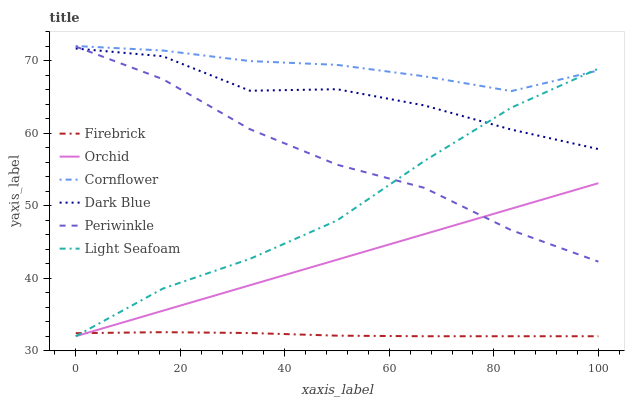Does Firebrick have the minimum area under the curve?
Answer yes or no. Yes. Does Cornflower have the maximum area under the curve?
Answer yes or no. Yes. Does Dark Blue have the minimum area under the curve?
Answer yes or no. No. Does Dark Blue have the maximum area under the curve?
Answer yes or no. No. Is Orchid the smoothest?
Answer yes or no. Yes. Is Dark Blue the roughest?
Answer yes or no. Yes. Is Firebrick the smoothest?
Answer yes or no. No. Is Firebrick the roughest?
Answer yes or no. No. Does Firebrick have the lowest value?
Answer yes or no. Yes. Does Dark Blue have the lowest value?
Answer yes or no. No. Does Cornflower have the highest value?
Answer yes or no. Yes. Does Dark Blue have the highest value?
Answer yes or no. No. Is Firebrick less than Periwinkle?
Answer yes or no. Yes. Is Periwinkle greater than Firebrick?
Answer yes or no. Yes. Does Periwinkle intersect Orchid?
Answer yes or no. Yes. Is Periwinkle less than Orchid?
Answer yes or no. No. Is Periwinkle greater than Orchid?
Answer yes or no. No. Does Firebrick intersect Periwinkle?
Answer yes or no. No. 